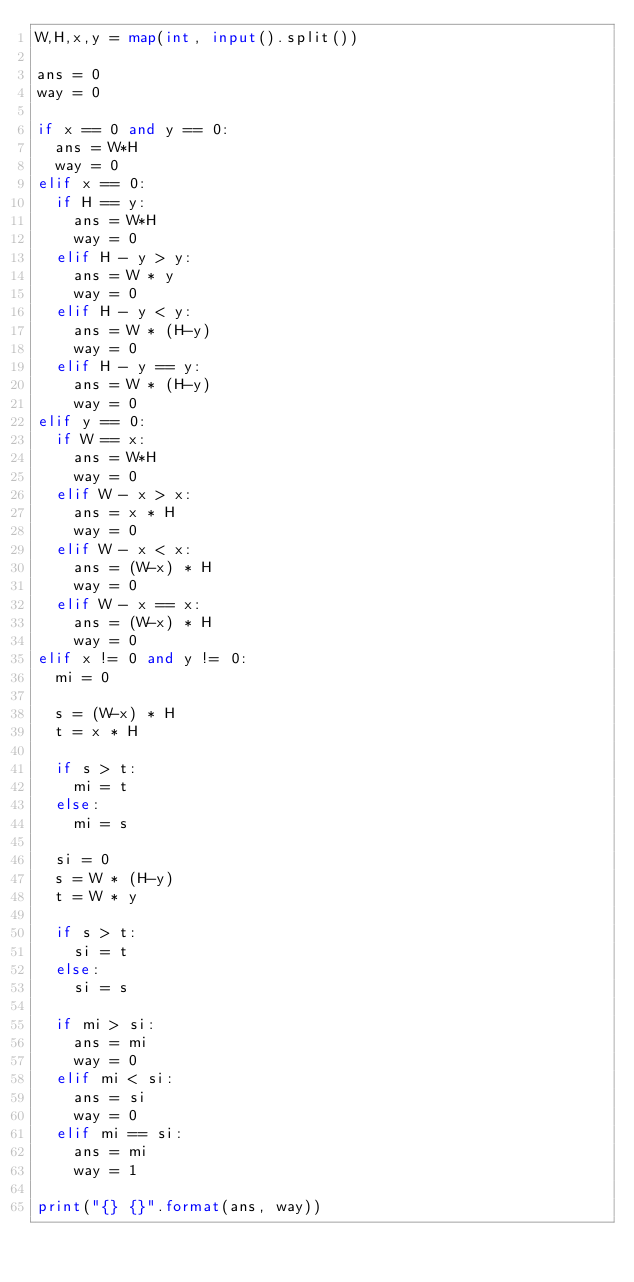Convert code to text. <code><loc_0><loc_0><loc_500><loc_500><_Python_>W,H,x,y = map(int, input().split())

ans = 0
way = 0

if x == 0 and y == 0:
  ans = W*H
  way = 0
elif x == 0:
  if H == y:
    ans = W*H
    way = 0
  elif H - y > y:
    ans = W * y
    way = 0
  elif H - y < y:
    ans = W * (H-y)
    way = 0
  elif H - y == y:
    ans = W * (H-y)
    way = 0
elif y == 0:
  if W == x:
    ans = W*H
    way = 0
  elif W - x > x:
    ans = x * H
    way = 0
  elif W - x < x:
    ans = (W-x) * H
    way = 0
  elif W - x == x:
    ans = (W-x) * H
    way = 0
elif x != 0 and y != 0:
  mi = 0

  s = (W-x) * H
  t = x * H

  if s > t:
    mi = t
  else:
    mi = s

  si = 0
  s = W * (H-y)
  t = W * y

  if s > t:
    si = t
  else:
    si = s

  if mi > si:
    ans = mi
    way = 0
  elif mi < si:
    ans = si
    way = 0
  elif mi == si:
    ans = mi
    way = 1

print("{} {}".format(ans, way))</code> 